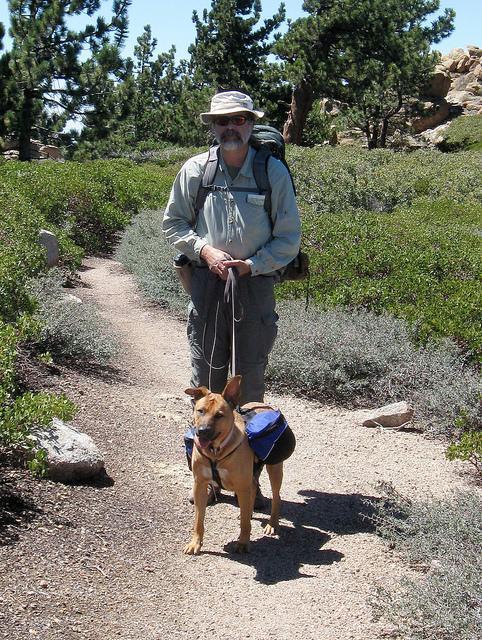How many chair legs are visible?
Give a very brief answer. 0. 